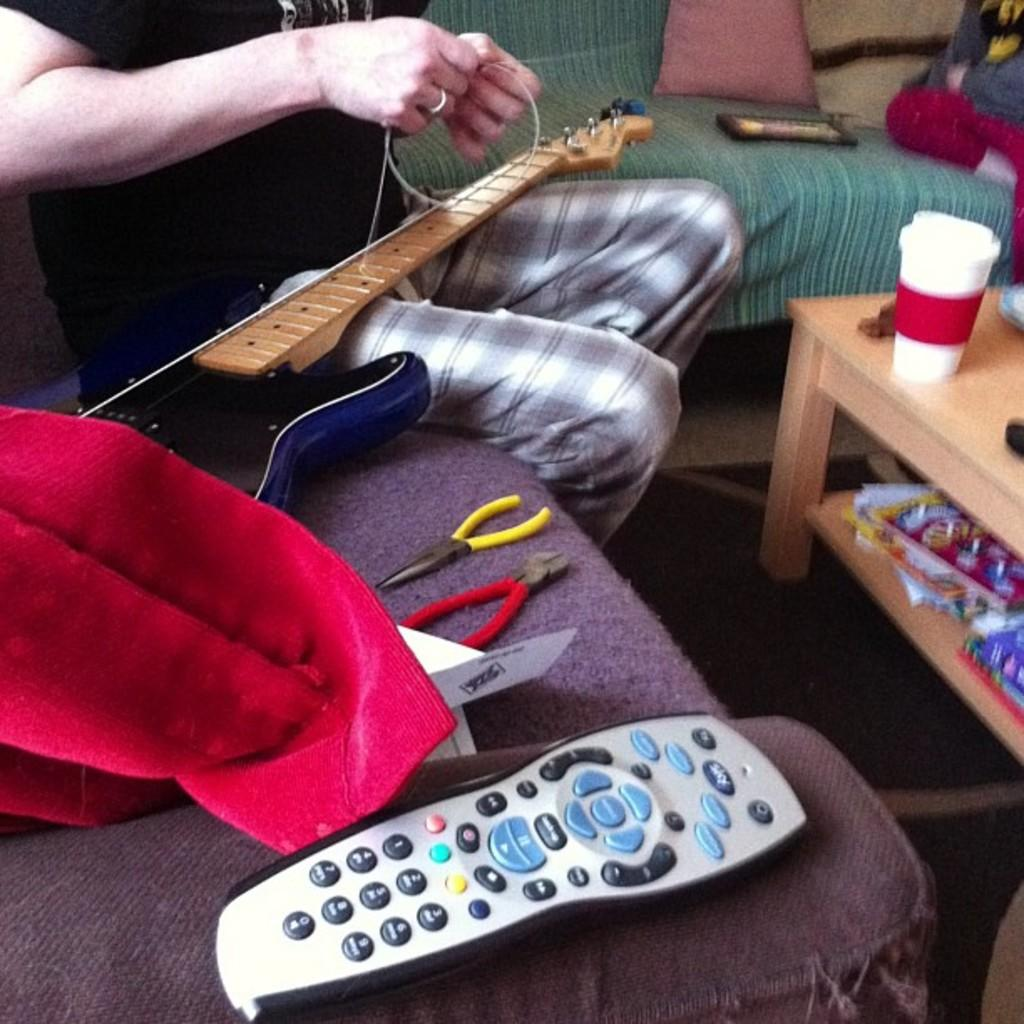<image>
Present a compact description of the photo's key features. the number 2 is on the remote that the person has 